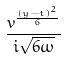<formula> <loc_0><loc_0><loc_500><loc_500>\frac { v ^ { \frac { ( y - t ) ^ { 2 } } { 6 } } } { i \sqrt { 6 \omega } }</formula> 